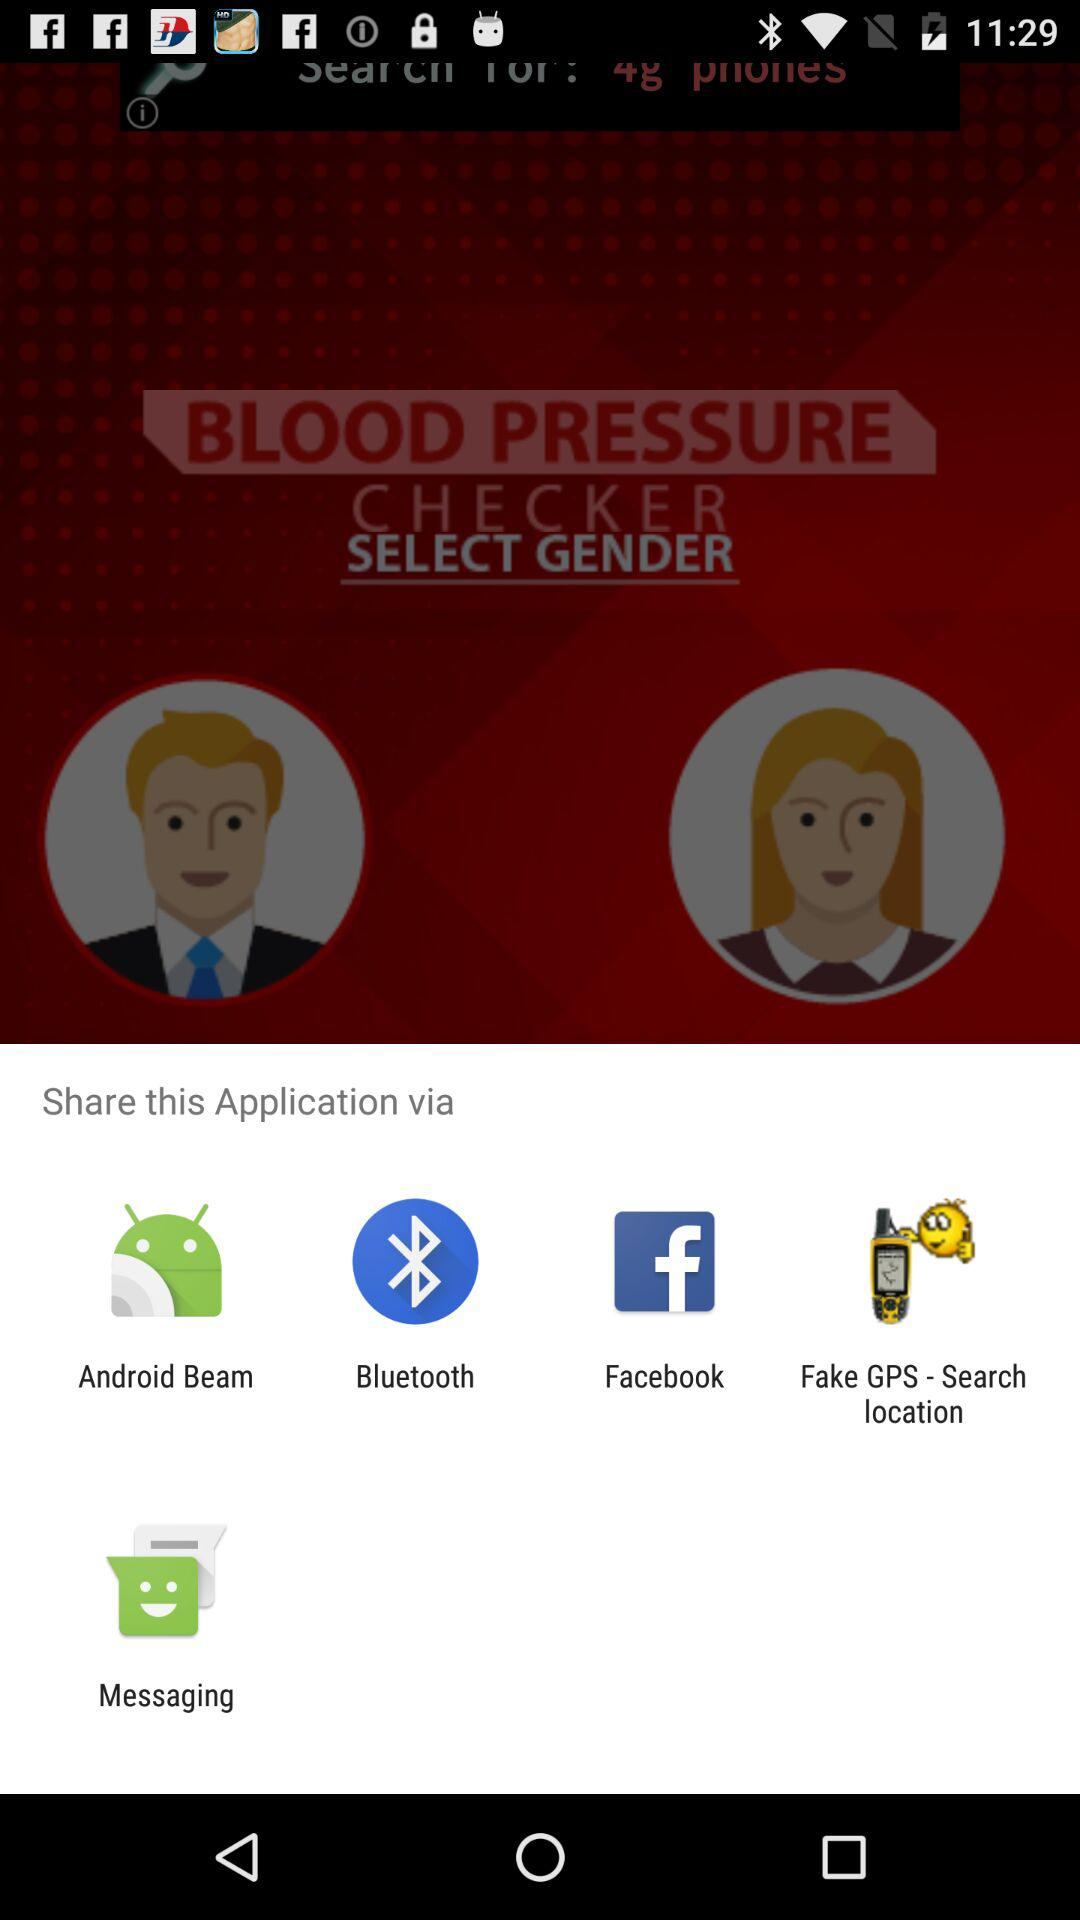By which app can we share it? You can share it by "Android Beam", "Bluetooth", "Facebook", "Fake GPS - Search location" and "Messaging". 